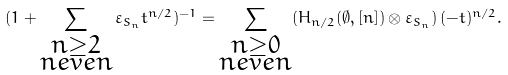Convert formula to latex. <formula><loc_0><loc_0><loc_500><loc_500>( 1 + \sum _ { \substack { n \geq 2 \\ n e v e n } } \varepsilon _ { S _ { n } } t ^ { n / 2 } ) ^ { - 1 } = \sum _ { \substack { n \geq 0 \\ n e v e n } } ( H _ { n / 2 } ( \emptyset , [ n ] ) \otimes \varepsilon _ { S _ { n } } ) \, ( - t ) ^ { n / 2 } .</formula> 